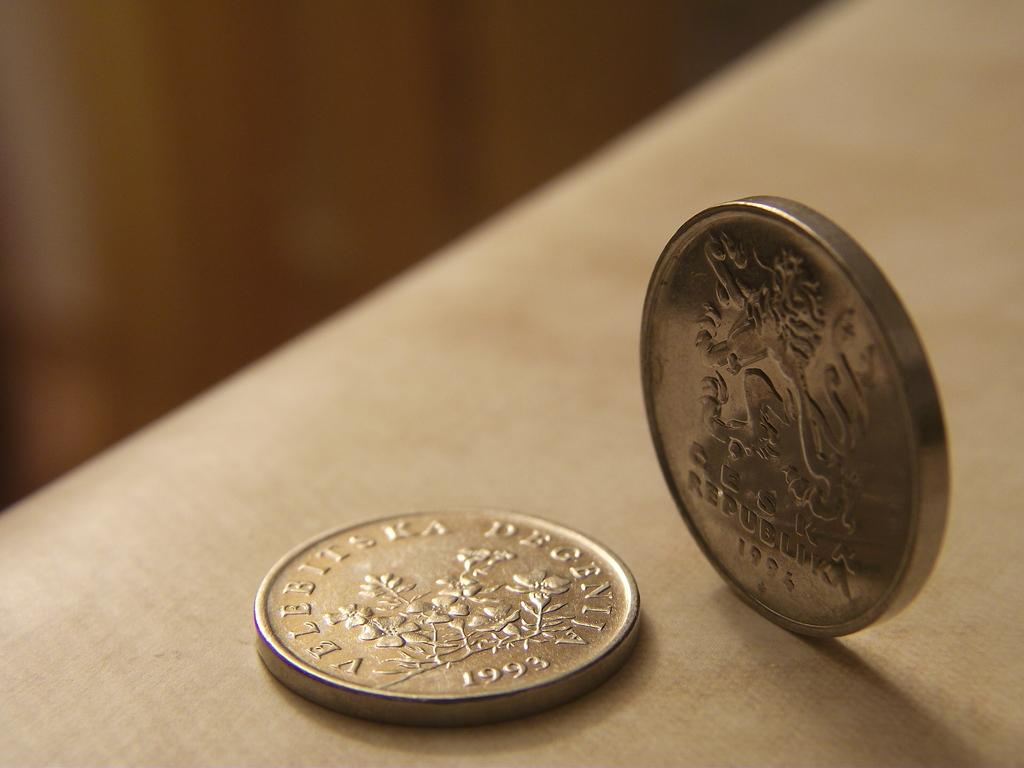<image>
Write a terse but informative summary of the picture. Gold coin with flowers and marked with Velbbitska degeniia 1993 